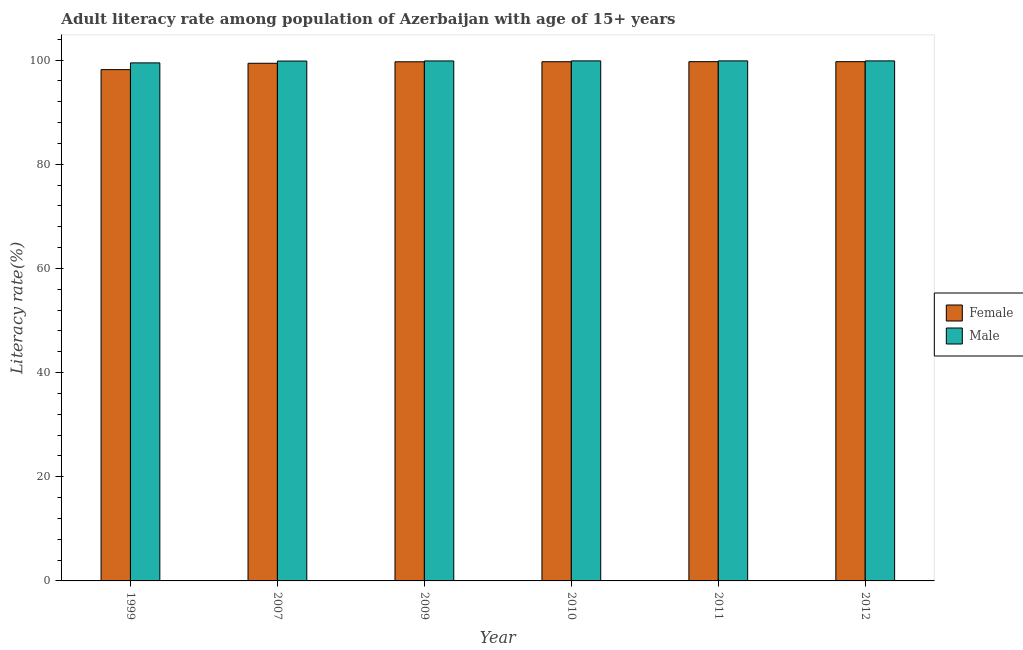Are the number of bars per tick equal to the number of legend labels?
Your answer should be compact. Yes. What is the label of the 3rd group of bars from the left?
Your answer should be very brief. 2009. What is the male adult literacy rate in 2012?
Your answer should be compact. 99.85. Across all years, what is the maximum female adult literacy rate?
Offer a very short reply. 99.7. Across all years, what is the minimum male adult literacy rate?
Provide a succinct answer. 99.47. In which year was the male adult literacy rate maximum?
Your answer should be compact. 2011. In which year was the female adult literacy rate minimum?
Offer a terse response. 1999. What is the total female adult literacy rate in the graph?
Give a very brief answer. 596.36. What is the difference between the male adult literacy rate in 2010 and that in 2012?
Keep it short and to the point. 0. What is the difference between the male adult literacy rate in 2009 and the female adult literacy rate in 2010?
Your answer should be very brief. -0.01. What is the average female adult literacy rate per year?
Keep it short and to the point. 99.39. In the year 2007, what is the difference between the male adult literacy rate and female adult literacy rate?
Offer a very short reply. 0. What is the ratio of the male adult literacy rate in 2010 to that in 2012?
Ensure brevity in your answer.  1. What is the difference between the highest and the second highest male adult literacy rate?
Ensure brevity in your answer.  0. What is the difference between the highest and the lowest male adult literacy rate?
Make the answer very short. 0.38. In how many years, is the male adult literacy rate greater than the average male adult literacy rate taken over all years?
Make the answer very short. 5. Is the sum of the male adult literacy rate in 1999 and 2010 greater than the maximum female adult literacy rate across all years?
Your answer should be very brief. Yes. How many bars are there?
Keep it short and to the point. 12. Are all the bars in the graph horizontal?
Offer a very short reply. No. What is the difference between two consecutive major ticks on the Y-axis?
Provide a succinct answer. 20. Are the values on the major ticks of Y-axis written in scientific E-notation?
Your answer should be very brief. No. Does the graph contain grids?
Your response must be concise. No. How are the legend labels stacked?
Your answer should be very brief. Vertical. What is the title of the graph?
Offer a terse response. Adult literacy rate among population of Azerbaijan with age of 15+ years. Does "National Visitors" appear as one of the legend labels in the graph?
Your response must be concise. No. What is the label or title of the Y-axis?
Your answer should be compact. Literacy rate(%). What is the Literacy rate(%) in Female in 1999?
Offer a very short reply. 98.17. What is the Literacy rate(%) in Male in 1999?
Offer a very short reply. 99.47. What is the Literacy rate(%) in Female in 2007?
Offer a terse response. 99.4. What is the Literacy rate(%) of Male in 2007?
Offer a terse response. 99.82. What is the Literacy rate(%) in Female in 2009?
Provide a short and direct response. 99.68. What is the Literacy rate(%) in Male in 2009?
Ensure brevity in your answer.  99.84. What is the Literacy rate(%) in Female in 2010?
Ensure brevity in your answer.  99.69. What is the Literacy rate(%) in Male in 2010?
Make the answer very short. 99.85. What is the Literacy rate(%) of Female in 2011?
Give a very brief answer. 99.7. What is the Literacy rate(%) of Male in 2011?
Offer a very short reply. 99.86. What is the Literacy rate(%) of Female in 2012?
Your response must be concise. 99.7. What is the Literacy rate(%) in Male in 2012?
Ensure brevity in your answer.  99.85. Across all years, what is the maximum Literacy rate(%) of Female?
Offer a terse response. 99.7. Across all years, what is the maximum Literacy rate(%) of Male?
Your answer should be compact. 99.86. Across all years, what is the minimum Literacy rate(%) of Female?
Provide a succinct answer. 98.17. Across all years, what is the minimum Literacy rate(%) in Male?
Offer a terse response. 99.47. What is the total Literacy rate(%) in Female in the graph?
Your response must be concise. 596.36. What is the total Literacy rate(%) in Male in the graph?
Make the answer very short. 598.7. What is the difference between the Literacy rate(%) in Female in 1999 and that in 2007?
Offer a very short reply. -1.22. What is the difference between the Literacy rate(%) of Male in 1999 and that in 2007?
Make the answer very short. -0.35. What is the difference between the Literacy rate(%) in Female in 1999 and that in 2009?
Ensure brevity in your answer.  -1.51. What is the difference between the Literacy rate(%) in Male in 1999 and that in 2009?
Your response must be concise. -0.37. What is the difference between the Literacy rate(%) of Female in 1999 and that in 2010?
Your answer should be very brief. -1.52. What is the difference between the Literacy rate(%) of Male in 1999 and that in 2010?
Offer a terse response. -0.38. What is the difference between the Literacy rate(%) of Female in 1999 and that in 2011?
Make the answer very short. -1.53. What is the difference between the Literacy rate(%) in Male in 1999 and that in 2011?
Provide a succinct answer. -0.38. What is the difference between the Literacy rate(%) of Female in 1999 and that in 2012?
Provide a succinct answer. -1.53. What is the difference between the Literacy rate(%) in Male in 1999 and that in 2012?
Offer a terse response. -0.38. What is the difference between the Literacy rate(%) in Female in 2007 and that in 2009?
Provide a succinct answer. -0.28. What is the difference between the Literacy rate(%) in Male in 2007 and that in 2009?
Provide a short and direct response. -0.02. What is the difference between the Literacy rate(%) in Female in 2007 and that in 2010?
Offer a very short reply. -0.29. What is the difference between the Literacy rate(%) of Male in 2007 and that in 2010?
Provide a succinct answer. -0.03. What is the difference between the Literacy rate(%) of Female in 2007 and that in 2011?
Offer a very short reply. -0.31. What is the difference between the Literacy rate(%) in Male in 2007 and that in 2011?
Provide a short and direct response. -0.03. What is the difference between the Literacy rate(%) of Female in 2007 and that in 2012?
Keep it short and to the point. -0.3. What is the difference between the Literacy rate(%) of Male in 2007 and that in 2012?
Provide a succinct answer. -0.03. What is the difference between the Literacy rate(%) of Female in 2009 and that in 2010?
Keep it short and to the point. -0.01. What is the difference between the Literacy rate(%) of Male in 2009 and that in 2010?
Give a very brief answer. -0.01. What is the difference between the Literacy rate(%) in Female in 2009 and that in 2011?
Ensure brevity in your answer.  -0.02. What is the difference between the Literacy rate(%) of Male in 2009 and that in 2011?
Your answer should be very brief. -0.01. What is the difference between the Literacy rate(%) of Female in 2009 and that in 2012?
Provide a succinct answer. -0.02. What is the difference between the Literacy rate(%) in Male in 2009 and that in 2012?
Give a very brief answer. -0.01. What is the difference between the Literacy rate(%) in Female in 2010 and that in 2011?
Your response must be concise. -0.01. What is the difference between the Literacy rate(%) of Male in 2010 and that in 2011?
Your response must be concise. -0. What is the difference between the Literacy rate(%) in Female in 2010 and that in 2012?
Give a very brief answer. -0.01. What is the difference between the Literacy rate(%) of Male in 2010 and that in 2012?
Offer a terse response. 0. What is the difference between the Literacy rate(%) of Female in 2011 and that in 2012?
Make the answer very short. 0. What is the difference between the Literacy rate(%) in Male in 2011 and that in 2012?
Offer a very short reply. 0. What is the difference between the Literacy rate(%) of Female in 1999 and the Literacy rate(%) of Male in 2007?
Offer a terse response. -1.65. What is the difference between the Literacy rate(%) in Female in 1999 and the Literacy rate(%) in Male in 2009?
Make the answer very short. -1.67. What is the difference between the Literacy rate(%) of Female in 1999 and the Literacy rate(%) of Male in 2010?
Provide a succinct answer. -1.68. What is the difference between the Literacy rate(%) in Female in 1999 and the Literacy rate(%) in Male in 2011?
Provide a short and direct response. -1.68. What is the difference between the Literacy rate(%) of Female in 1999 and the Literacy rate(%) of Male in 2012?
Give a very brief answer. -1.68. What is the difference between the Literacy rate(%) in Female in 2007 and the Literacy rate(%) in Male in 2009?
Make the answer very short. -0.44. What is the difference between the Literacy rate(%) in Female in 2007 and the Literacy rate(%) in Male in 2010?
Offer a terse response. -0.46. What is the difference between the Literacy rate(%) in Female in 2007 and the Literacy rate(%) in Male in 2011?
Your answer should be compact. -0.46. What is the difference between the Literacy rate(%) in Female in 2007 and the Literacy rate(%) in Male in 2012?
Provide a succinct answer. -0.46. What is the difference between the Literacy rate(%) in Female in 2009 and the Literacy rate(%) in Male in 2010?
Provide a short and direct response. -0.17. What is the difference between the Literacy rate(%) of Female in 2009 and the Literacy rate(%) of Male in 2011?
Give a very brief answer. -0.17. What is the difference between the Literacy rate(%) of Female in 2009 and the Literacy rate(%) of Male in 2012?
Provide a succinct answer. -0.17. What is the difference between the Literacy rate(%) in Female in 2010 and the Literacy rate(%) in Male in 2011?
Your answer should be very brief. -0.16. What is the difference between the Literacy rate(%) of Female in 2010 and the Literacy rate(%) of Male in 2012?
Keep it short and to the point. -0.16. What is the difference between the Literacy rate(%) of Female in 2011 and the Literacy rate(%) of Male in 2012?
Ensure brevity in your answer.  -0.15. What is the average Literacy rate(%) in Female per year?
Your answer should be compact. 99.39. What is the average Literacy rate(%) of Male per year?
Offer a terse response. 99.78. In the year 1999, what is the difference between the Literacy rate(%) of Female and Literacy rate(%) of Male?
Provide a succinct answer. -1.3. In the year 2007, what is the difference between the Literacy rate(%) of Female and Literacy rate(%) of Male?
Offer a very short reply. -0.43. In the year 2009, what is the difference between the Literacy rate(%) of Female and Literacy rate(%) of Male?
Your answer should be very brief. -0.16. In the year 2010, what is the difference between the Literacy rate(%) of Female and Literacy rate(%) of Male?
Give a very brief answer. -0.16. In the year 2011, what is the difference between the Literacy rate(%) in Female and Literacy rate(%) in Male?
Make the answer very short. -0.15. What is the ratio of the Literacy rate(%) in Female in 1999 to that in 2009?
Your answer should be compact. 0.98. What is the ratio of the Literacy rate(%) in Male in 1999 to that in 2009?
Provide a succinct answer. 1. What is the ratio of the Literacy rate(%) of Male in 1999 to that in 2010?
Provide a short and direct response. 1. What is the ratio of the Literacy rate(%) of Female in 1999 to that in 2011?
Offer a terse response. 0.98. What is the ratio of the Literacy rate(%) of Female in 1999 to that in 2012?
Provide a short and direct response. 0.98. What is the ratio of the Literacy rate(%) in Female in 2007 to that in 2009?
Your response must be concise. 1. What is the ratio of the Literacy rate(%) in Female in 2007 to that in 2010?
Provide a succinct answer. 1. What is the ratio of the Literacy rate(%) of Female in 2007 to that in 2012?
Keep it short and to the point. 1. What is the ratio of the Literacy rate(%) of Male in 2007 to that in 2012?
Your answer should be very brief. 1. What is the ratio of the Literacy rate(%) in Female in 2009 to that in 2010?
Offer a terse response. 1. What is the ratio of the Literacy rate(%) of Female in 2009 to that in 2012?
Offer a very short reply. 1. What is the ratio of the Literacy rate(%) of Male in 2010 to that in 2011?
Offer a terse response. 1. What is the ratio of the Literacy rate(%) of Male in 2010 to that in 2012?
Keep it short and to the point. 1. What is the ratio of the Literacy rate(%) in Female in 2011 to that in 2012?
Make the answer very short. 1. What is the ratio of the Literacy rate(%) of Male in 2011 to that in 2012?
Provide a short and direct response. 1. What is the difference between the highest and the second highest Literacy rate(%) in Female?
Your answer should be compact. 0. What is the difference between the highest and the second highest Literacy rate(%) in Male?
Make the answer very short. 0. What is the difference between the highest and the lowest Literacy rate(%) of Female?
Your response must be concise. 1.53. What is the difference between the highest and the lowest Literacy rate(%) in Male?
Your answer should be compact. 0.38. 